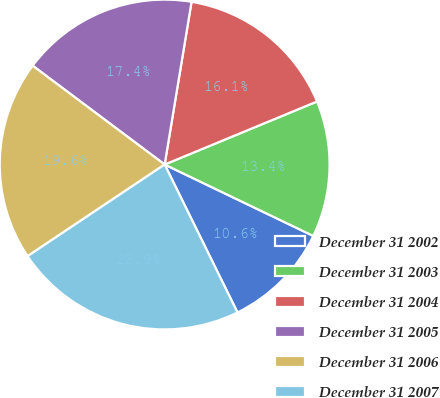<chart> <loc_0><loc_0><loc_500><loc_500><pie_chart><fcel>December 31 2002<fcel>December 31 2003<fcel>December 31 2004<fcel>December 31 2005<fcel>December 31 2006<fcel>December 31 2007<nl><fcel>10.59%<fcel>13.37%<fcel>16.15%<fcel>17.38%<fcel>19.61%<fcel>22.9%<nl></chart> 